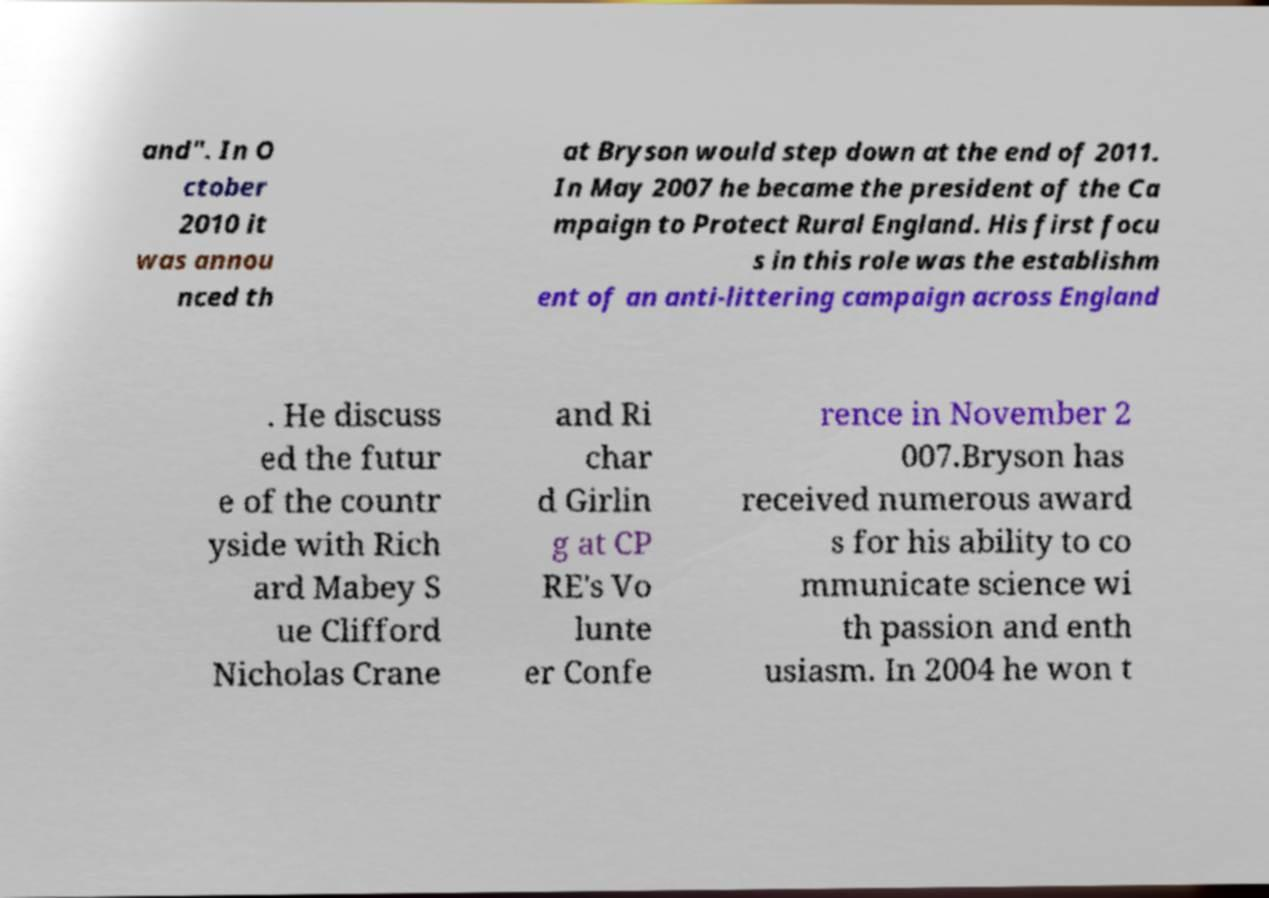For documentation purposes, I need the text within this image transcribed. Could you provide that? and". In O ctober 2010 it was annou nced th at Bryson would step down at the end of 2011. In May 2007 he became the president of the Ca mpaign to Protect Rural England. His first focu s in this role was the establishm ent of an anti-littering campaign across England . He discuss ed the futur e of the countr yside with Rich ard Mabey S ue Clifford Nicholas Crane and Ri char d Girlin g at CP RE's Vo lunte er Confe rence in November 2 007.Bryson has received numerous award s for his ability to co mmunicate science wi th passion and enth usiasm. In 2004 he won t 